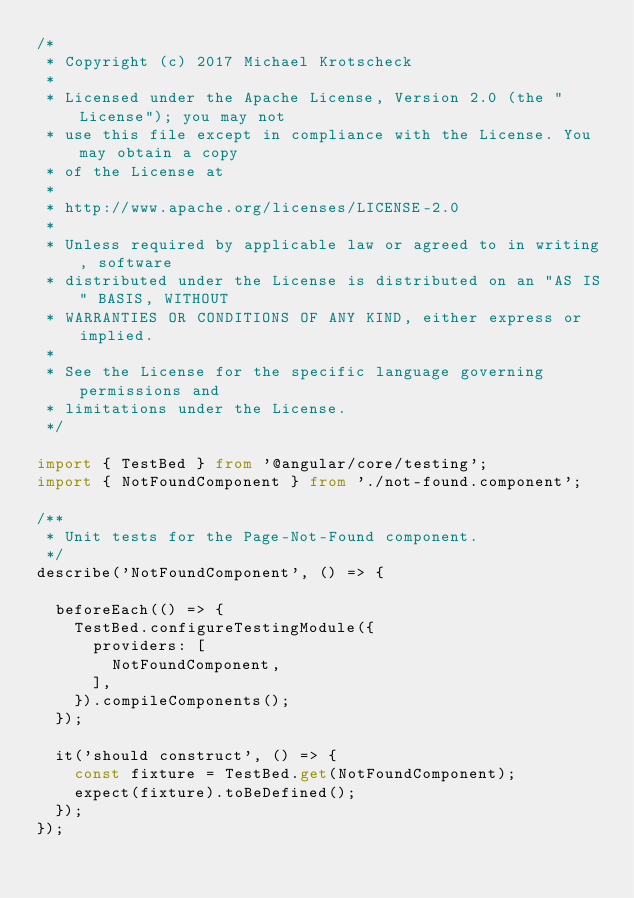Convert code to text. <code><loc_0><loc_0><loc_500><loc_500><_TypeScript_>/*
 * Copyright (c) 2017 Michael Krotscheck
 *
 * Licensed under the Apache License, Version 2.0 (the "License"); you may not
 * use this file except in compliance with the License. You may obtain a copy
 * of the License at
 *
 * http://www.apache.org/licenses/LICENSE-2.0
 *
 * Unless required by applicable law or agreed to in writing, software
 * distributed under the License is distributed on an "AS IS" BASIS, WITHOUT
 * WARRANTIES OR CONDITIONS OF ANY KIND, either express or implied.
 *
 * See the License for the specific language governing permissions and
 * limitations under the License.
 */

import { TestBed } from '@angular/core/testing';
import { NotFoundComponent } from './not-found.component';

/**
 * Unit tests for the Page-Not-Found component.
 */
describe('NotFoundComponent', () => {

  beforeEach(() => {
    TestBed.configureTestingModule({
      providers: [
        NotFoundComponent,
      ],
    }).compileComponents();
  });

  it('should construct', () => {
    const fixture = TestBed.get(NotFoundComponent);
    expect(fixture).toBeDefined();
  });
});
</code> 